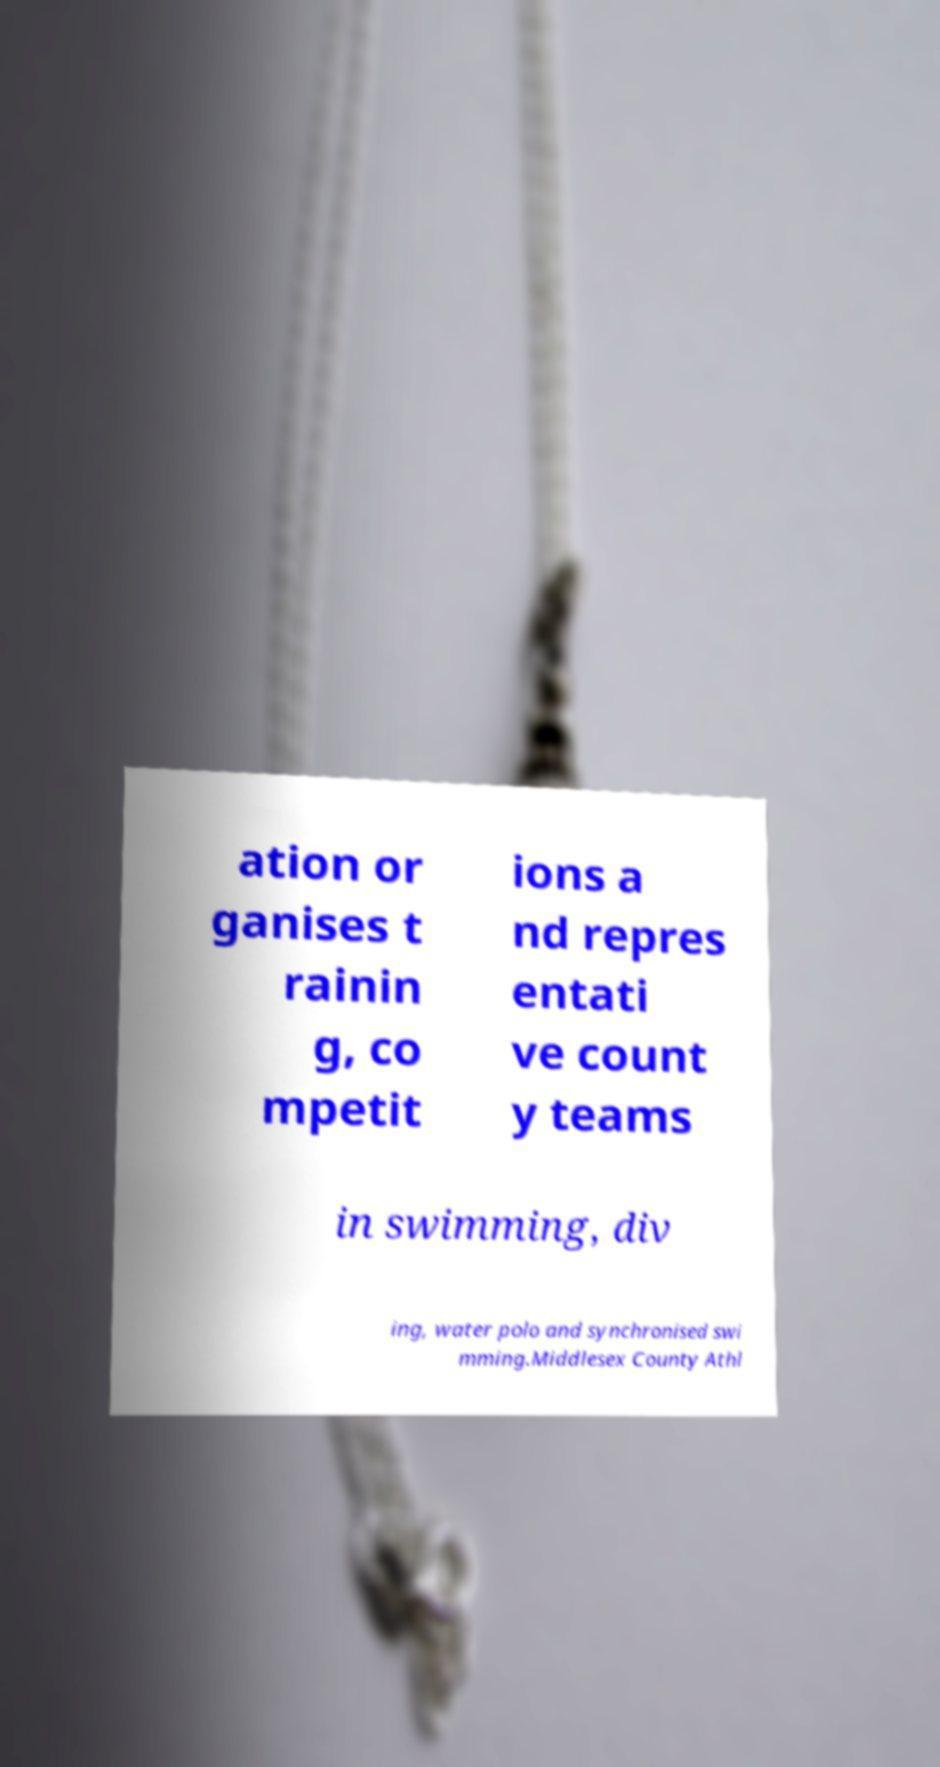Could you extract and type out the text from this image? ation or ganises t rainin g, co mpetit ions a nd repres entati ve count y teams in swimming, div ing, water polo and synchronised swi mming.Middlesex County Athl 